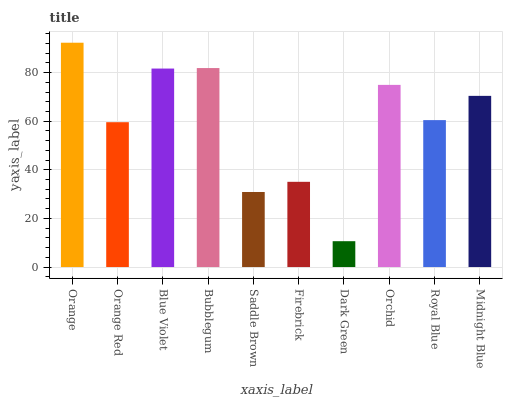Is Dark Green the minimum?
Answer yes or no. Yes. Is Orange the maximum?
Answer yes or no. Yes. Is Orange Red the minimum?
Answer yes or no. No. Is Orange Red the maximum?
Answer yes or no. No. Is Orange greater than Orange Red?
Answer yes or no. Yes. Is Orange Red less than Orange?
Answer yes or no. Yes. Is Orange Red greater than Orange?
Answer yes or no. No. Is Orange less than Orange Red?
Answer yes or no. No. Is Midnight Blue the high median?
Answer yes or no. Yes. Is Royal Blue the low median?
Answer yes or no. Yes. Is Saddle Brown the high median?
Answer yes or no. No. Is Blue Violet the low median?
Answer yes or no. No. 